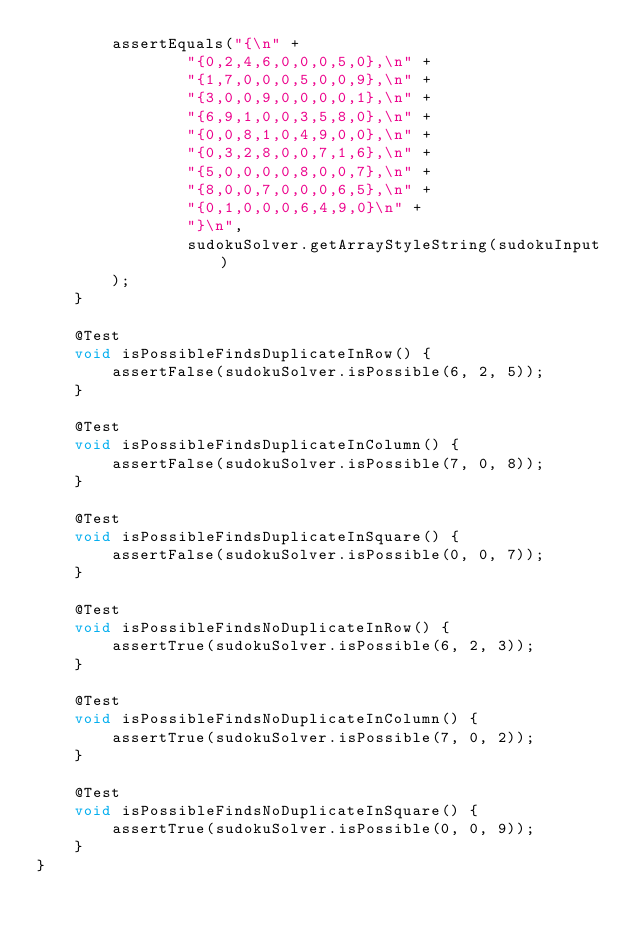Convert code to text. <code><loc_0><loc_0><loc_500><loc_500><_Java_>        assertEquals("{\n" +
                "{0,2,4,6,0,0,0,5,0},\n" +
                "{1,7,0,0,0,5,0,0,9},\n" +
                "{3,0,0,9,0,0,0,0,1},\n" +
                "{6,9,1,0,0,3,5,8,0},\n" +
                "{0,0,8,1,0,4,9,0,0},\n" +
                "{0,3,2,8,0,0,7,1,6},\n" +
                "{5,0,0,0,0,8,0,0,7},\n" +
                "{8,0,0,7,0,0,0,6,5},\n" +
                "{0,1,0,0,0,6,4,9,0}\n" +
                "}\n",
                sudokuSolver.getArrayStyleString(sudokuInput)
        );
    }

    @Test
    void isPossibleFindsDuplicateInRow() {
        assertFalse(sudokuSolver.isPossible(6, 2, 5));
    }

    @Test
    void isPossibleFindsDuplicateInColumn() {
        assertFalse(sudokuSolver.isPossible(7, 0, 8));
    }

    @Test
    void isPossibleFindsDuplicateInSquare() {
        assertFalse(sudokuSolver.isPossible(0, 0, 7));
    }

    @Test
    void isPossibleFindsNoDuplicateInRow() {
        assertTrue(sudokuSolver.isPossible(6, 2, 3));
    }

    @Test
    void isPossibleFindsNoDuplicateInColumn() {
        assertTrue(sudokuSolver.isPossible(7, 0, 2));
    }

    @Test
    void isPossibleFindsNoDuplicateInSquare() {
        assertTrue(sudokuSolver.isPossible(0, 0, 9));
    }
}</code> 